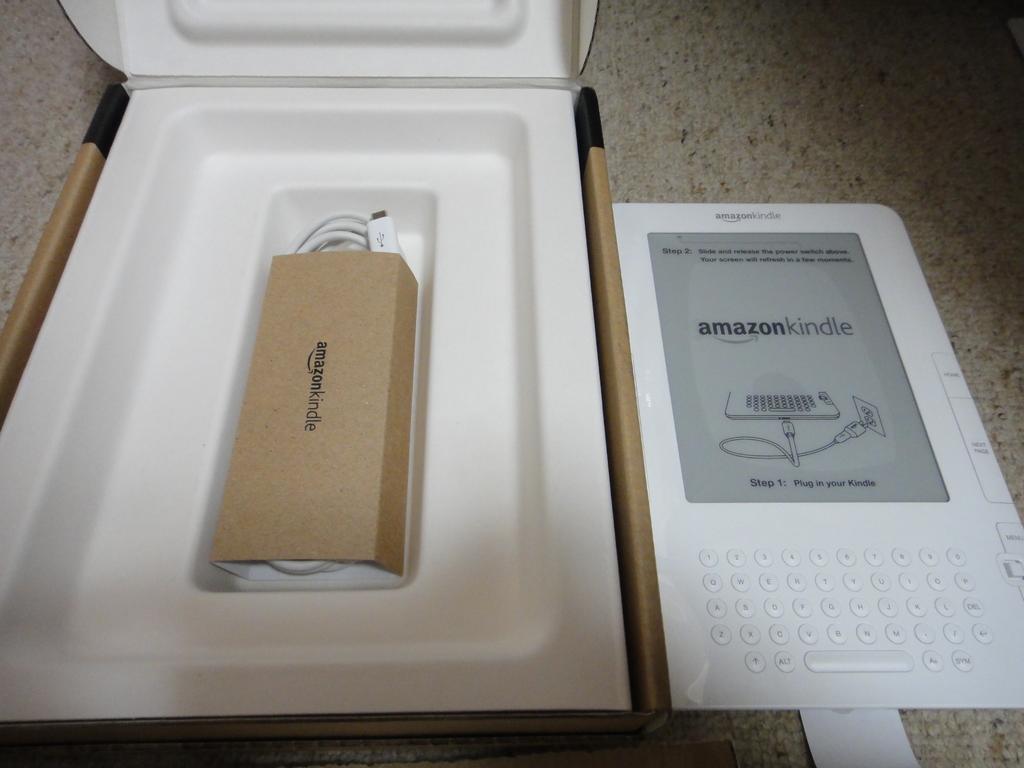What brand is this product?
Provide a short and direct response. Amazon. 